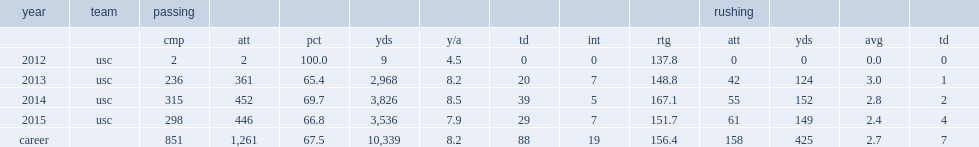How many passing yards did cody kessler get in his career? 10339.0. 